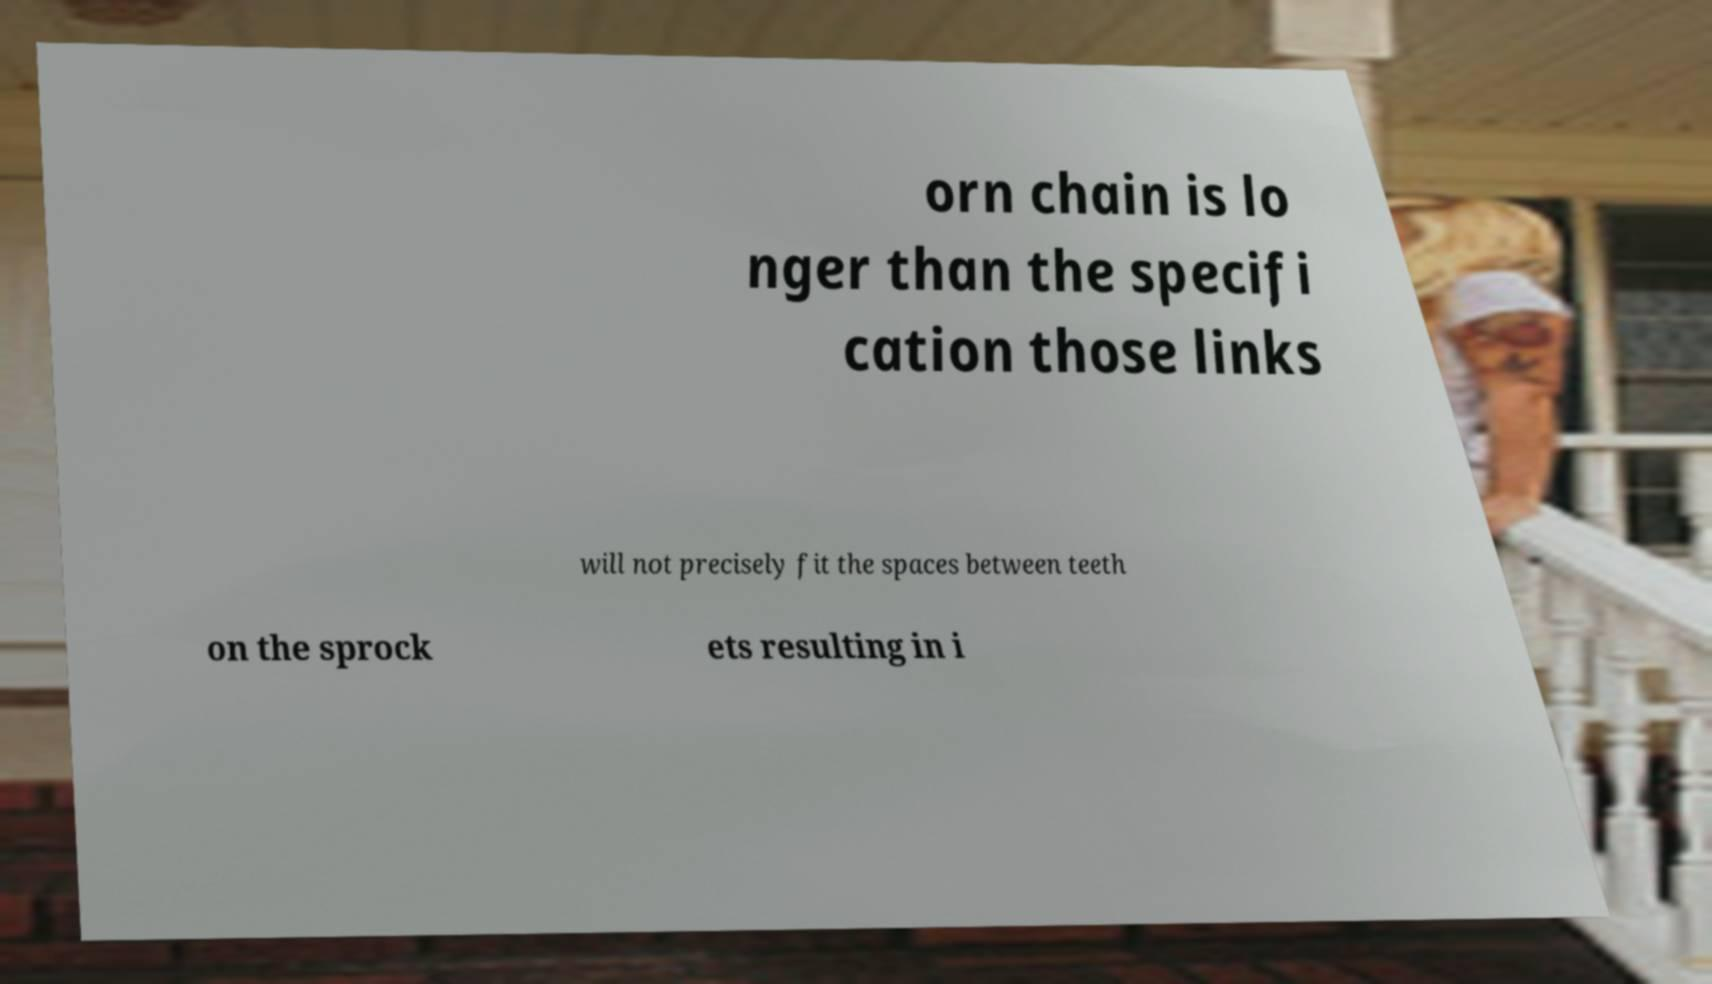Can you accurately transcribe the text from the provided image for me? orn chain is lo nger than the specifi cation those links will not precisely fit the spaces between teeth on the sprock ets resulting in i 